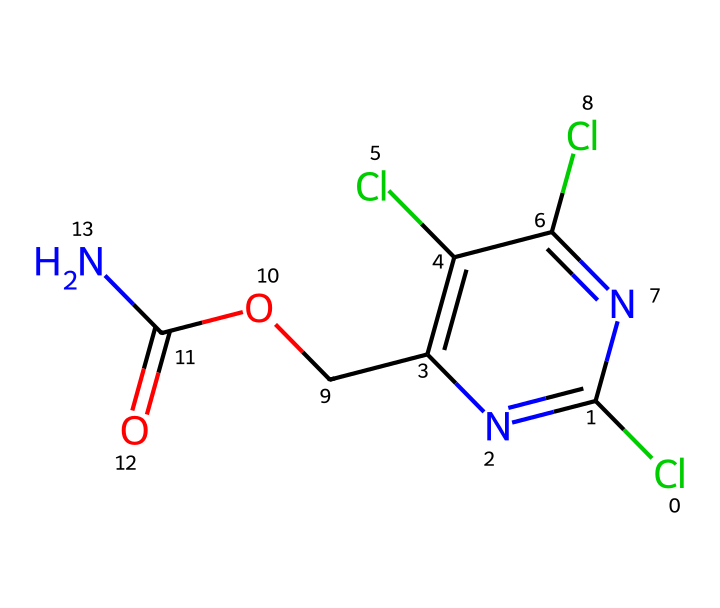What is the molecular formula of triclopyr? To find the molecular formula, count the number of each type of atom in the SMILES representation. The atoms present include Carbon (C), Chlorine (Cl), Nitrogen (N), and Oxygen (O). After counting the atoms represented, the molecular formula is determined to be C7H6Cl3N3O2.
Answer: C7H6Cl3N3O2 How many nitrogen atoms are in triclopyr? By examining the SMILES representation, each nitrogen atom is represented by "N." Counting the occurrences gives a total of three nitrogen atoms in the structure.
Answer: 3 What type of plants is triclopyr used to control? Triclopyr is specifically used to control woody and broadleaf plants, as indicated by its classification as a herbicide.
Answer: woody and broadleaf What functional group is present in triclopyr that indicates it is a herbicide? The presence of the carboxylate functional group (indicated by the C(=O)O fragment in the structure) is characteristic of herbicides, as it contributes to the biological activity against plants.
Answer: carboxylate How many chlorine atoms are present in the structure of triclopyr? In the SMILES representation, each chlorine atom is represented by "Cl." By counting the occurrences in the structure, we find that there are three chlorine atoms.
Answer: 3 What is the significance of the nitrogen atoms in triclopyr's structure? The nitrogen atoms in triclopyr indicate the presence of amine groups, which can influence the herbicide's activity and interaction with plant systems as they facilitate biological activity against targeted species.
Answer: amine groups What is the main application of triclopyr in agriculture or forestry? Triclopyr's main application is for the control of unwanted vegetation, particularly in areas such as forests where invasive species are prevalent, aiding in the management of ecosystems.
Answer: vegetation control 